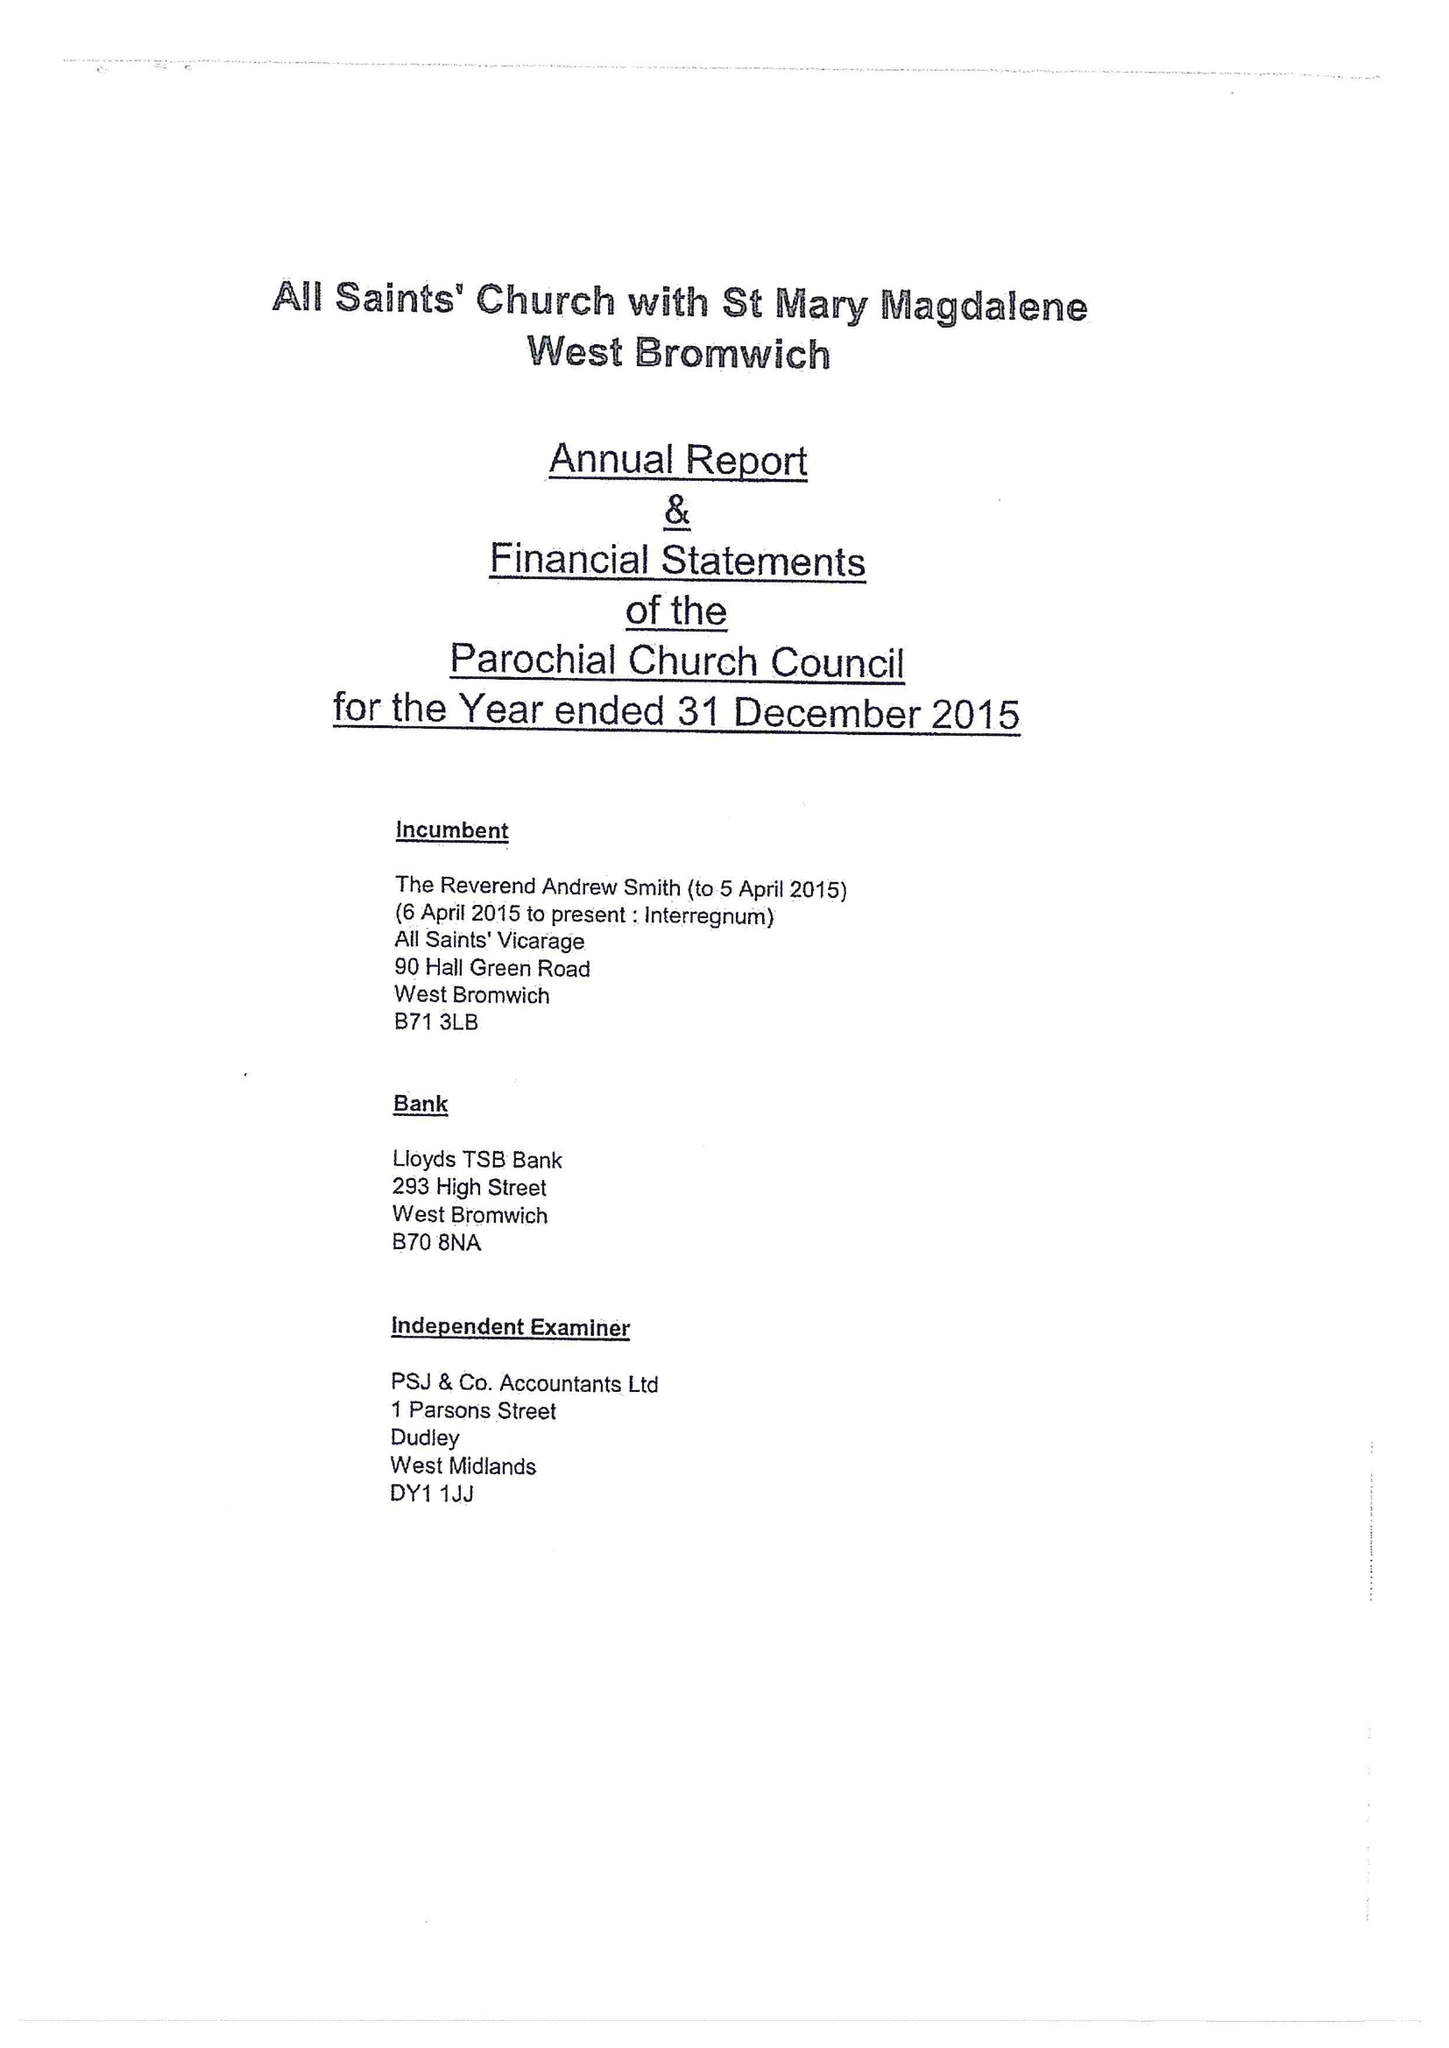What is the value for the address__post_town?
Answer the question using a single word or phrase. BIRMINGHAM 